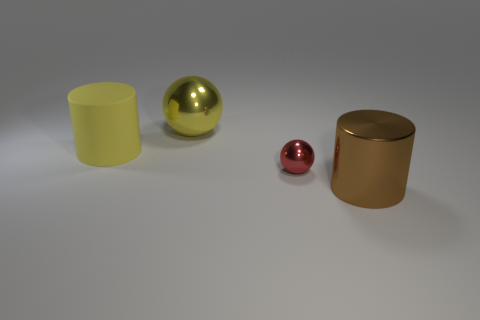What number of objects are either tiny spheres or yellow metallic balls behind the tiny metallic thing?
Keep it short and to the point. 2. Are there any other large things that have the same shape as the yellow rubber thing?
Keep it short and to the point. Yes. Are there an equal number of big brown things that are on the left side of the tiny shiny object and metal things in front of the large metal ball?
Your answer should be very brief. No. Is there any other thing that is the same size as the red metallic ball?
Make the answer very short. No. What number of purple things are either big shiny balls or rubber objects?
Offer a terse response. 0. What number of matte objects have the same size as the yellow matte cylinder?
Make the answer very short. 0. What is the color of the shiny thing that is behind the big brown metallic cylinder and to the right of the large yellow sphere?
Keep it short and to the point. Red. Is the number of big yellow metallic balls that are behind the tiny object greater than the number of tiny gray rubber blocks?
Offer a terse response. Yes. Are any purple blocks visible?
Your answer should be compact. No. Do the big sphere and the large matte thing have the same color?
Provide a succinct answer. Yes. 